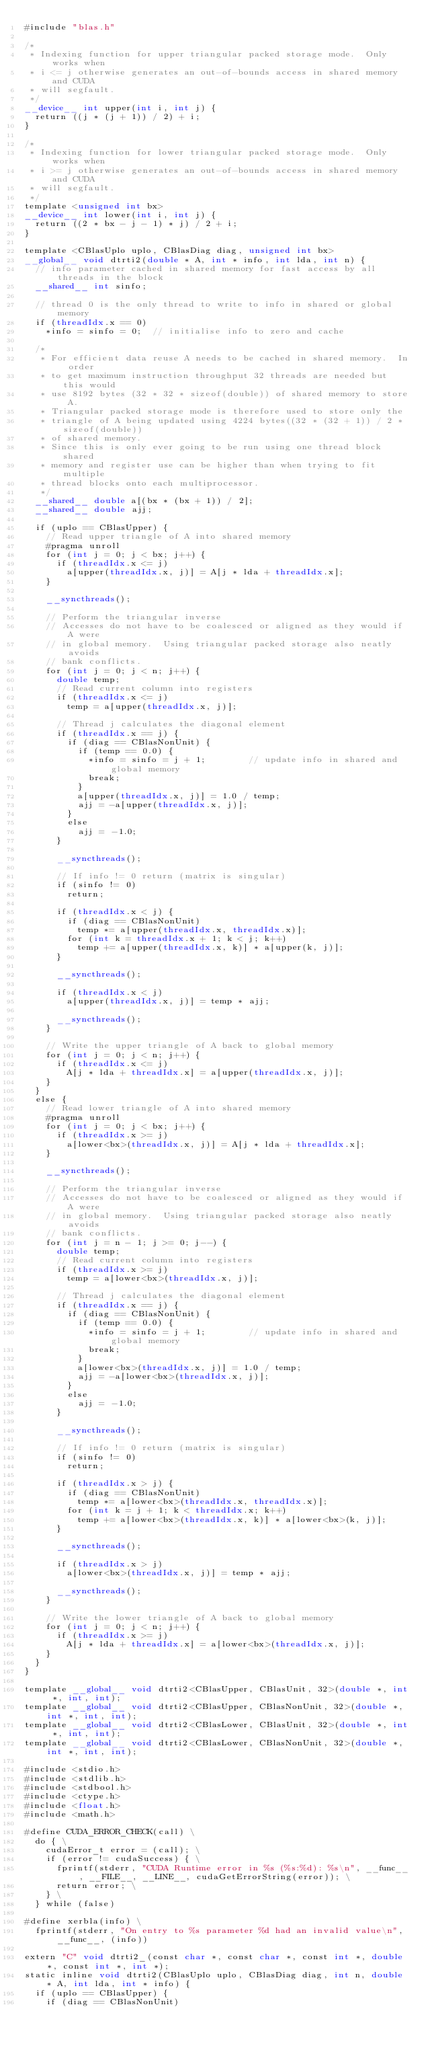<code> <loc_0><loc_0><loc_500><loc_500><_Cuda_>#include "blas.h"

/*
 * Indexing function for upper triangular packed storage mode.  Only works when
 * i <= j otherwise generates an out-of-bounds access in shared memory and CUDA
 * will segfault.
 */
__device__ int upper(int i, int j) {
  return ((j * (j + 1)) / 2) + i;
}

/*
 * Indexing function for lower triangular packed storage mode.  Only works when
 * i >= j otherwise generates an out-of-bounds access in shared memory and CUDA
 * will segfault.
 */
template <unsigned int bx>
__device__ int lower(int i, int j) {
  return ((2 * bx - j - 1) * j) / 2 + i;
}

template <CBlasUplo uplo, CBlasDiag diag, unsigned int bx>
__global__ void dtrti2(double * A, int * info, int lda, int n) {
  // info parameter cached in shared memory for fast access by all threads in the block
  __shared__ int sinfo;

  // thread 0 is the only thread to write to info in shared or global memory
  if (threadIdx.x == 0)
    *info = sinfo = 0;  // initialise info to zero and cache

  /*
   * For efficient data reuse A needs to be cached in shared memory.  In order
   * to get maximum instruction throughput 32 threads are needed but this would
   * use 8192 bytes (32 * 32 * sizeof(double)) of shared memory to store A.
   * Triangular packed storage mode is therefore used to store only the
   * triangle of A being updated using 4224 bytes((32 * (32 + 1)) / 2 * sizeof(double))
   * of shared memory.
   * Since this is only ever going to be run using one thread block shared
   * memory and register use can be higher than when trying to fit multiple
   * thread blocks onto each multiprocessor.
   */
  __shared__ double a[(bx * (bx + 1)) / 2];
  __shared__ double ajj;

  if (uplo == CBlasUpper) {
    // Read upper triangle of A into shared memory
    #pragma unroll
    for (int j = 0; j < bx; j++) {
      if (threadIdx.x <= j)
        a[upper(threadIdx.x, j)] = A[j * lda + threadIdx.x];
    }

    __syncthreads();

    // Perform the triangular inverse
    // Accesses do not have to be coalesced or aligned as they would if A were
    // in global memory.  Using triangular packed storage also neatly avoids
    // bank conflicts.
    for (int j = 0; j < n; j++) {
      double temp;
      // Read current column into registers
      if (threadIdx.x <= j)
        temp = a[upper(threadIdx.x, j)];

      // Thread j calculates the diagonal element
      if (threadIdx.x == j) {
        if (diag == CBlasNonUnit) {
          if (temp == 0.0) {
            *info = sinfo = j + 1;        // update info in shared and global memory
            break;
          }
          a[upper(threadIdx.x, j)] = 1.0 / temp;
          ajj = -a[upper(threadIdx.x, j)];
        }
        else
          ajj = -1.0;
      }

      __syncthreads();

      // If info != 0 return (matrix is singular)
      if (sinfo != 0)
        return;

      if (threadIdx.x < j) {
        if (diag == CBlasNonUnit)
          temp *= a[upper(threadIdx.x, threadIdx.x)];
        for (int k = threadIdx.x + 1; k < j; k++)
          temp += a[upper(threadIdx.x, k)] * a[upper(k, j)];
      }

      __syncthreads();

      if (threadIdx.x < j)
        a[upper(threadIdx.x, j)] = temp * ajj;

      __syncthreads();
    }

    // Write the upper triangle of A back to global memory
    for (int j = 0; j < n; j++) {
      if (threadIdx.x <= j)
        A[j * lda + threadIdx.x] = a[upper(threadIdx.x, j)];
    }
  }
  else {
    // Read lower triangle of A into shared memory
    #pragma unroll
    for (int j = 0; j < bx; j++) {
      if (threadIdx.x >= j)
        a[lower<bx>(threadIdx.x, j)] = A[j * lda + threadIdx.x];
    }

    __syncthreads();

    // Perform the triangular inverse
    // Accesses do not have to be coalesced or aligned as they would if A were
    // in global memory.  Using triangular packed storage also neatly avoids
    // bank conflicts.
    for (int j = n - 1; j >= 0; j--) {
      double temp;
      // Read current column into registers
      if (threadIdx.x >= j)
        temp = a[lower<bx>(threadIdx.x, j)];

      // Thread j calculates the diagonal element
      if (threadIdx.x == j) {
        if (diag == CBlasNonUnit) {
          if (temp == 0.0) {
            *info = sinfo = j + 1;        // update info in shared and global memory
            break;
          }
          a[lower<bx>(threadIdx.x, j)] = 1.0 / temp;
          ajj = -a[lower<bx>(threadIdx.x, j)];
        }
        else
          ajj = -1.0;
      }

      __syncthreads();

      // If info != 0 return (matrix is singular)
      if (sinfo != 0)
        return;

      if (threadIdx.x > j) {
        if (diag == CBlasNonUnit)
          temp *= a[lower<bx>(threadIdx.x, threadIdx.x)];
        for (int k = j + 1; k < threadIdx.x; k++)
          temp += a[lower<bx>(threadIdx.x, k)] * a[lower<bx>(k, j)];
      }

      __syncthreads();

      if (threadIdx.x > j)
        a[lower<bx>(threadIdx.x, j)] = temp * ajj;

      __syncthreads();
    }

    // Write the lower triangle of A back to global memory
    for (int j = 0; j < n; j++) {
      if (threadIdx.x >= j)
        A[j * lda + threadIdx.x] = a[lower<bx>(threadIdx.x, j)];
    }
  }
}

template __global__ void dtrti2<CBlasUpper, CBlasUnit, 32>(double *, int *, int, int);
template __global__ void dtrti2<CBlasUpper, CBlasNonUnit, 32>(double *, int *, int, int);
template __global__ void dtrti2<CBlasLower, CBlasUnit, 32>(double *, int *, int, int);
template __global__ void dtrti2<CBlasLower, CBlasNonUnit, 32>(double *, int *, int, int);

#include <stdio.h>
#include <stdlib.h>
#include <stdbool.h>
#include <ctype.h>
#include <float.h>
#include <math.h>

#define CUDA_ERROR_CHECK(call) \
  do { \
    cudaError_t error = (call); \
    if (error != cudaSuccess) { \
      fprintf(stderr, "CUDA Runtime error in %s (%s:%d): %s\n", __func__, __FILE__, __LINE__, cudaGetErrorString(error)); \
      return error; \
    } \
  } while (false)

#define xerbla(info) \
  fprintf(stderr, "On entry to %s parameter %d had an invalid value\n", __func__, (info))

extern "C" void dtrti2_(const char *, const char *, const int *, double *, const int *, int *);
static inline void dtrti2(CBlasUplo uplo, CBlasDiag diag, int n, double * A, int lda, int * info) {
  if (uplo == CBlasUpper) {
    if (diag == CBlasNonUnit)</code> 